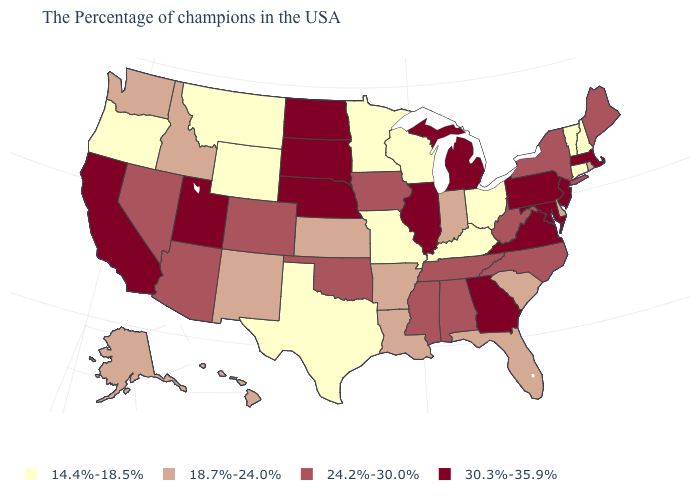What is the value of Connecticut?
Keep it brief. 14.4%-18.5%. Does the first symbol in the legend represent the smallest category?
Be succinct. Yes. What is the value of New Jersey?
Answer briefly. 30.3%-35.9%. Does the map have missing data?
Write a very short answer. No. What is the value of Indiana?
Write a very short answer. 18.7%-24.0%. What is the highest value in the Northeast ?
Be succinct. 30.3%-35.9%. What is the value of New York?
Quick response, please. 24.2%-30.0%. Does New Jersey have the highest value in the Northeast?
Short answer required. Yes. What is the value of Mississippi?
Short answer required. 24.2%-30.0%. What is the value of South Dakota?
Keep it brief. 30.3%-35.9%. What is the lowest value in the USA?
Write a very short answer. 14.4%-18.5%. What is the lowest value in states that border Oregon?
Short answer required. 18.7%-24.0%. Which states hav the highest value in the MidWest?
Write a very short answer. Michigan, Illinois, Nebraska, South Dakota, North Dakota. Does the map have missing data?
Keep it brief. No. 